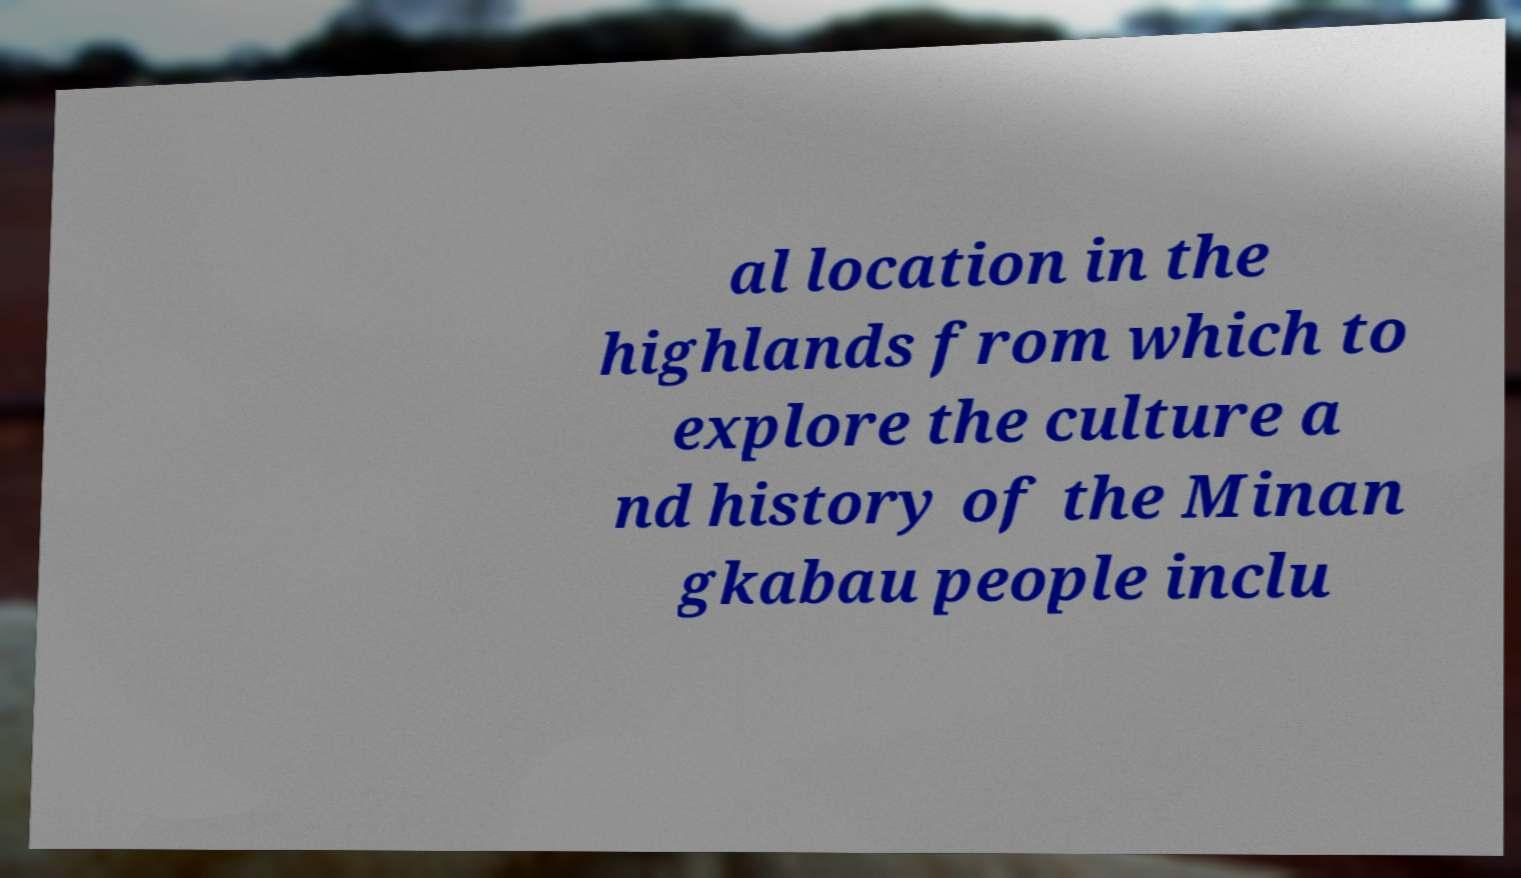Can you read and provide the text displayed in the image?This photo seems to have some interesting text. Can you extract and type it out for me? al location in the highlands from which to explore the culture a nd history of the Minan gkabau people inclu 